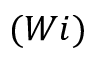Convert formula to latex. <formula><loc_0><loc_0><loc_500><loc_500>( W i )</formula> 